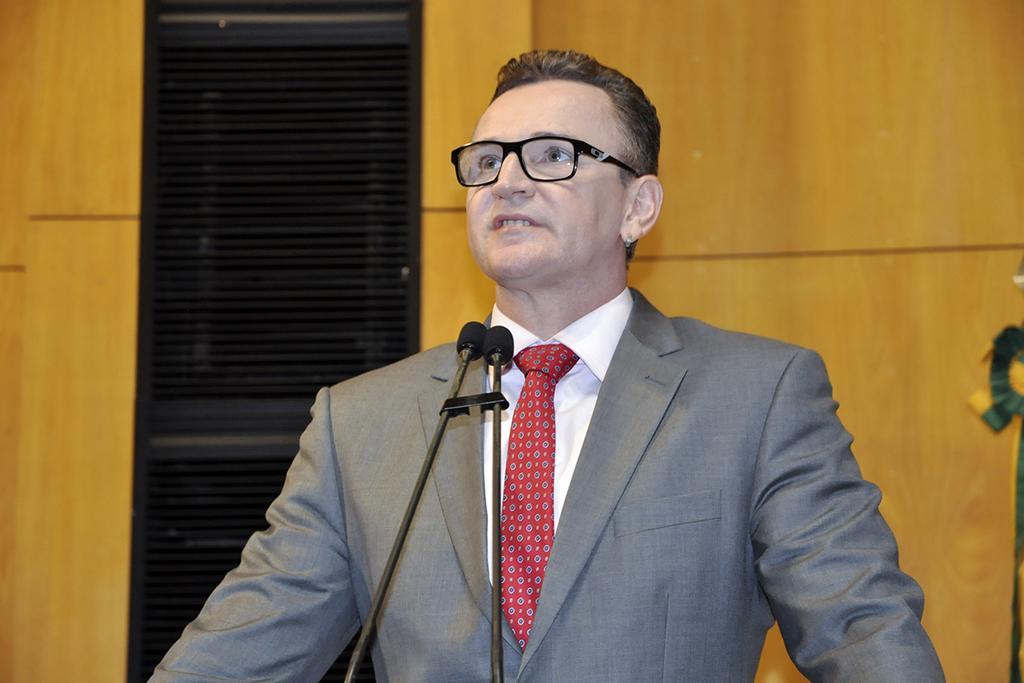Could you give a brief overview of what you see in this image? In the image in the center we can see one person standing. In front of him,we can see two microphones. In the background there is a wooden door and few other objects. 